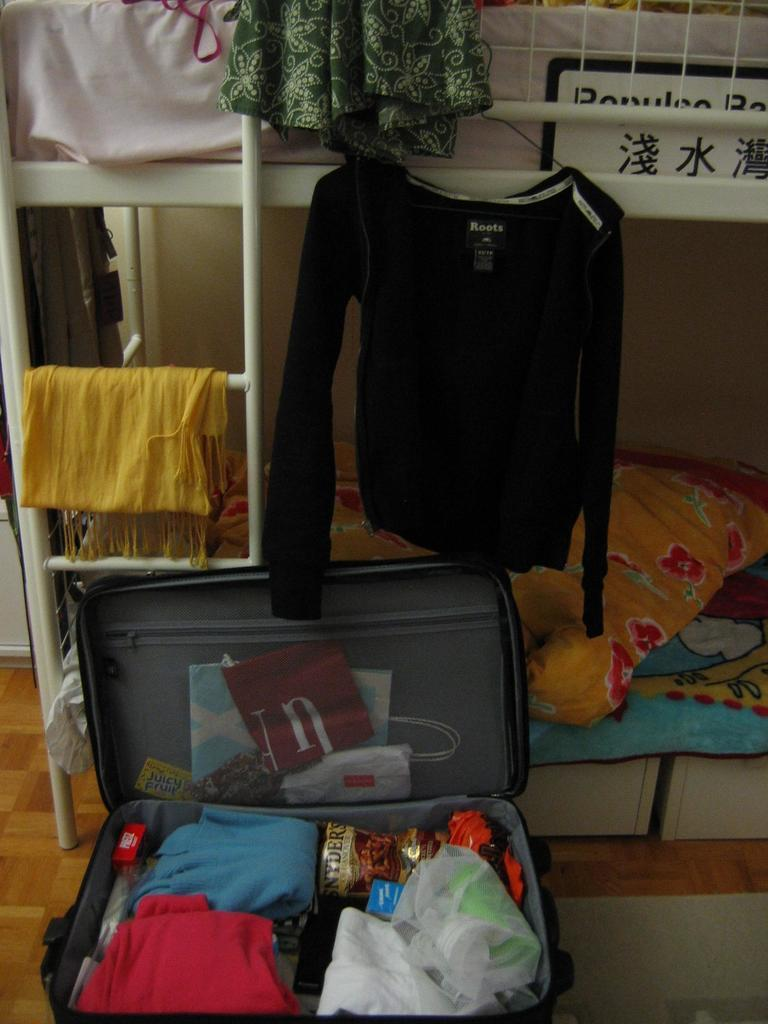What object can be seen in the image that is commonly used for carrying items? There is a briefcase in the image. What is inside the briefcase? The briefcase contains clothes. What piece of furniture is present in the image that is used for sleeping or resting? There is a bed in the image. What invention is being demonstrated in the image? There is no invention being demonstrated in the image; it features a briefcase containing clothes and a bed. How many people are jumping on the bed in the image? There are no people jumping on the bed in the image; it is not mentioned or depicted. 